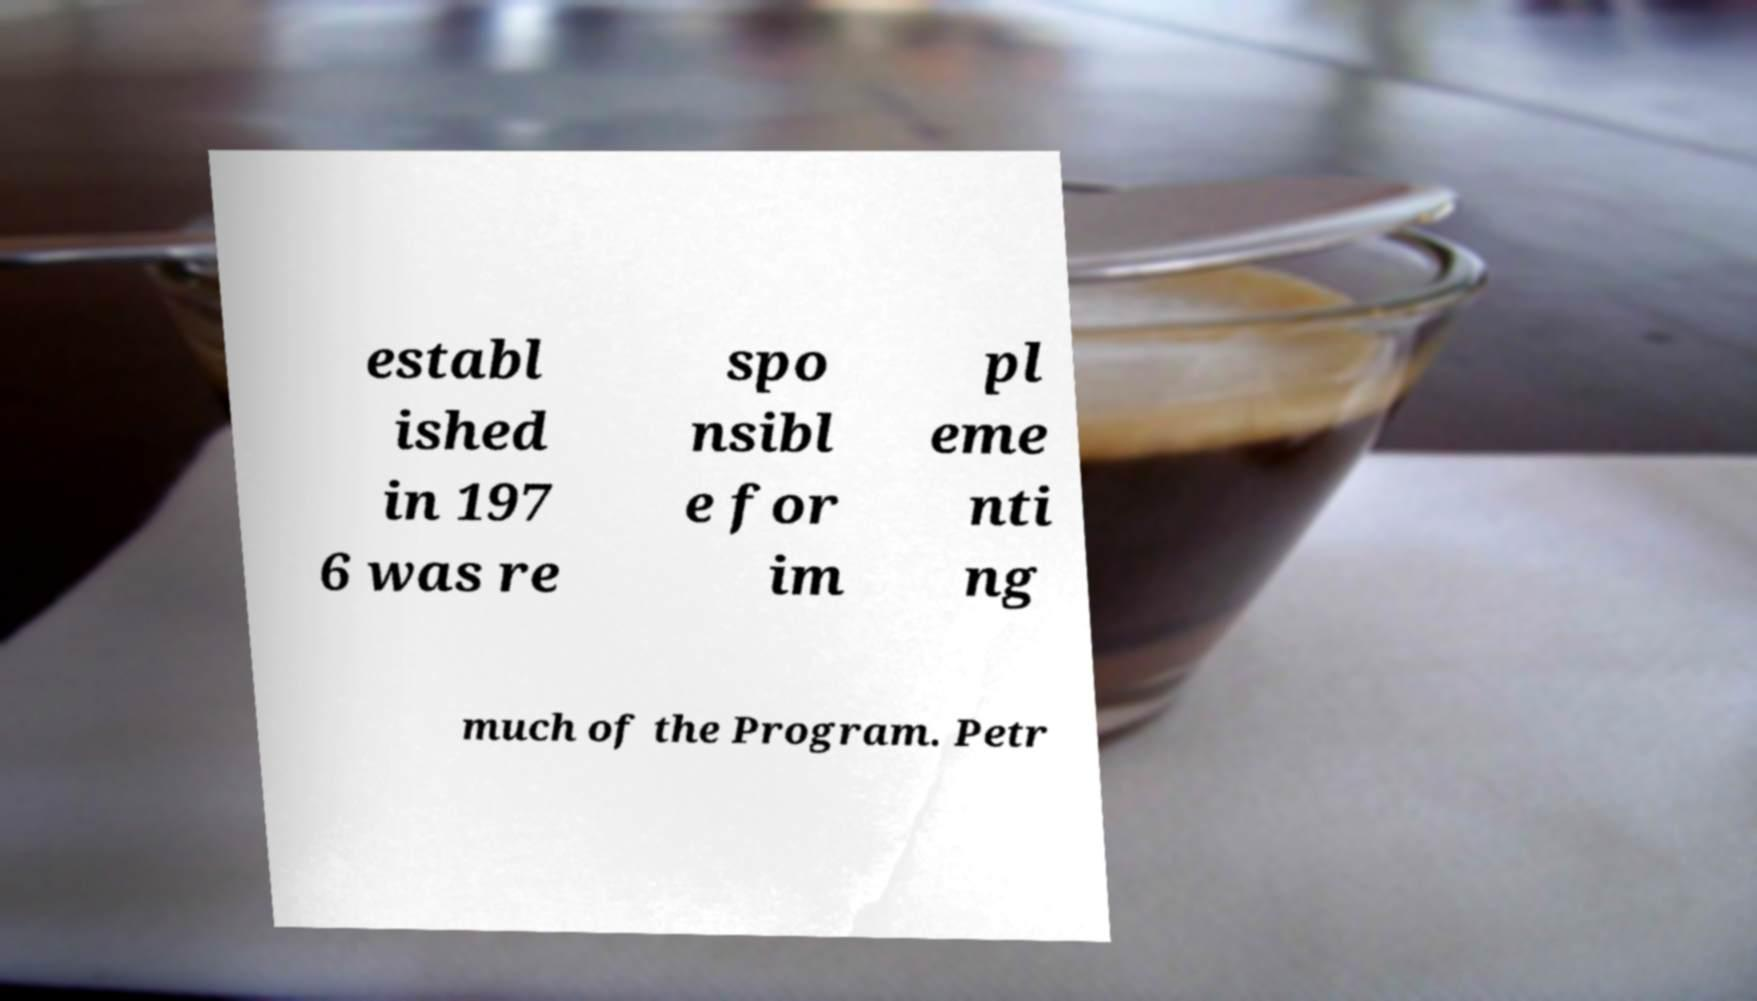There's text embedded in this image that I need extracted. Can you transcribe it verbatim? establ ished in 197 6 was re spo nsibl e for im pl eme nti ng much of the Program. Petr 